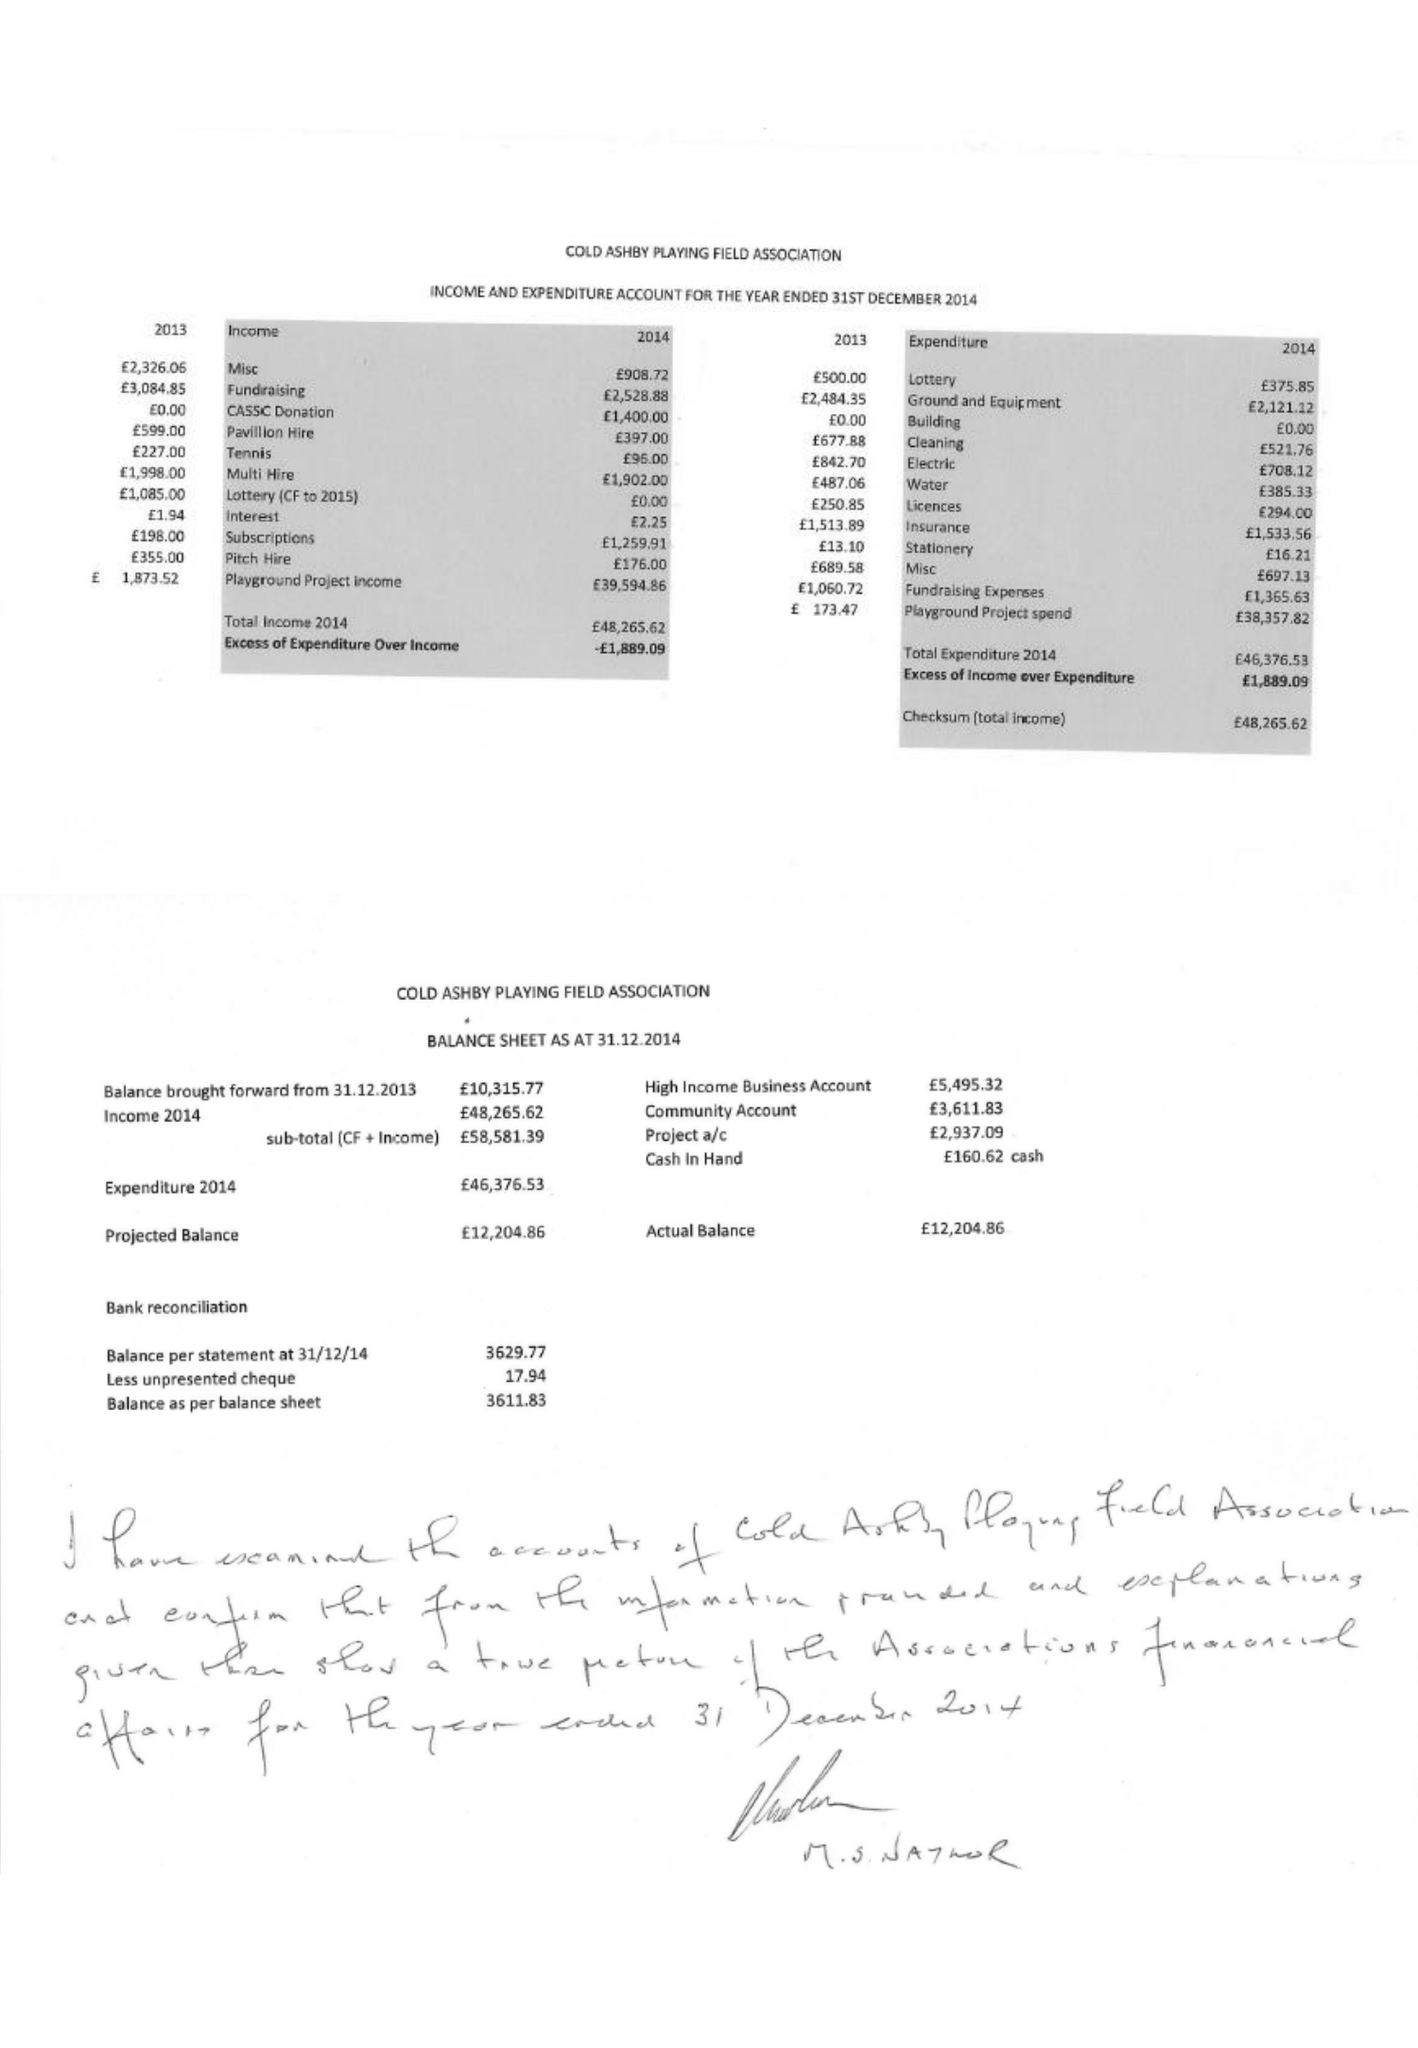What is the value for the spending_annually_in_british_pounds?
Answer the question using a single word or phrase. 46377.00 